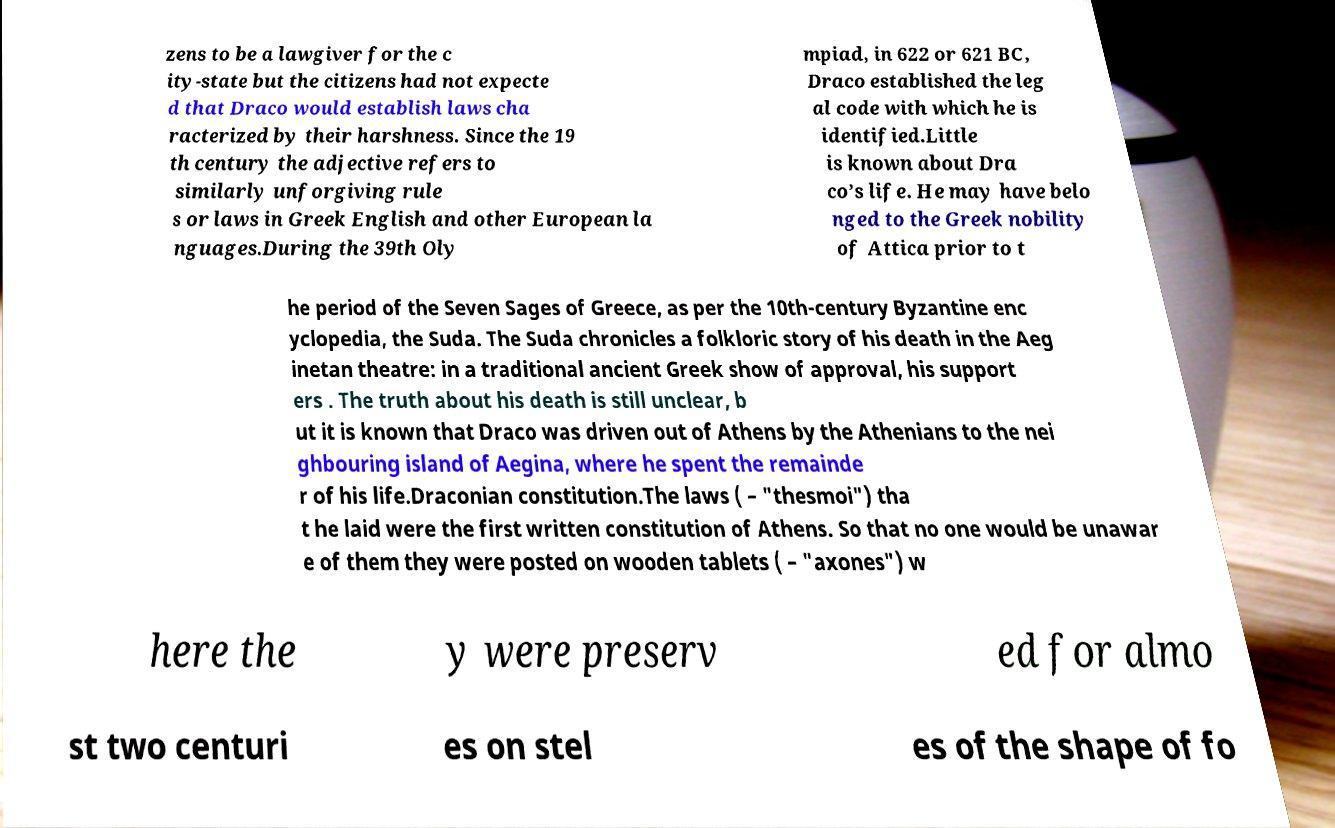Can you read and provide the text displayed in the image?This photo seems to have some interesting text. Can you extract and type it out for me? zens to be a lawgiver for the c ity-state but the citizens had not expecte d that Draco would establish laws cha racterized by their harshness. Since the 19 th century the adjective refers to similarly unforgiving rule s or laws in Greek English and other European la nguages.During the 39th Oly mpiad, in 622 or 621 BC, Draco established the leg al code with which he is identified.Little is known about Dra co’s life. He may have belo nged to the Greek nobility of Attica prior to t he period of the Seven Sages of Greece, as per the 10th-century Byzantine enc yclopedia, the Suda. The Suda chronicles a folkloric story of his death in the Aeg inetan theatre: in a traditional ancient Greek show of approval, his support ers . The truth about his death is still unclear, b ut it is known that Draco was driven out of Athens by the Athenians to the nei ghbouring island of Aegina, where he spent the remainde r of his life.Draconian constitution.The laws ( – "thesmoi") tha t he laid were the first written constitution of Athens. So that no one would be unawar e of them they were posted on wooden tablets ( – "axones") w here the y were preserv ed for almo st two centuri es on stel es of the shape of fo 